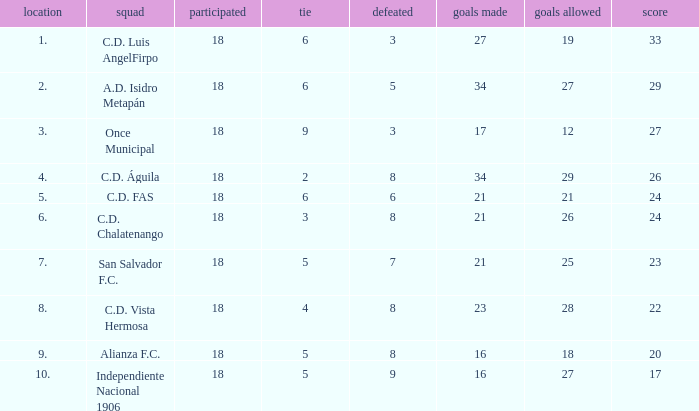How many goals are let in for a player who has participated over 18 times? 0.0. 